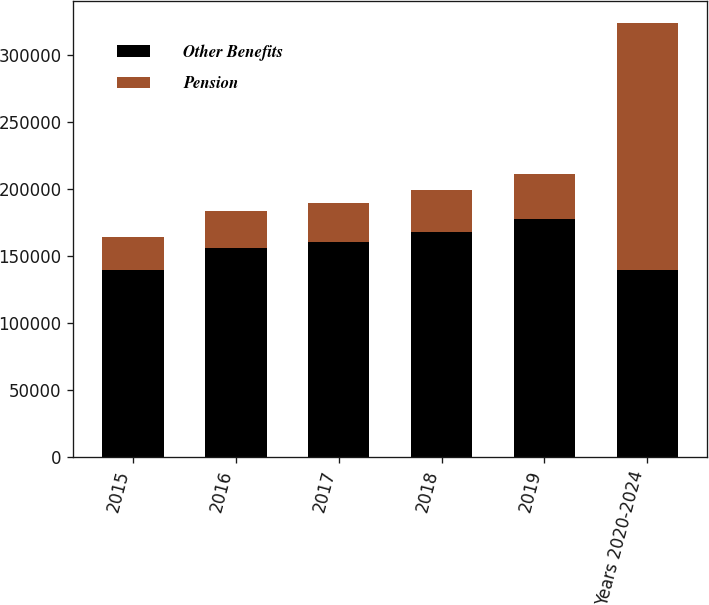Convert chart to OTSL. <chart><loc_0><loc_0><loc_500><loc_500><stacked_bar_chart><ecel><fcel>2015<fcel>2016<fcel>2017<fcel>2018<fcel>2019<fcel>Years 2020-2024<nl><fcel>Other Benefits<fcel>139013<fcel>155968<fcel>160080<fcel>167600<fcel>177470<fcel>139013<nl><fcel>Pension<fcel>25134<fcel>27311<fcel>29253<fcel>31258<fcel>33190<fcel>184772<nl></chart> 